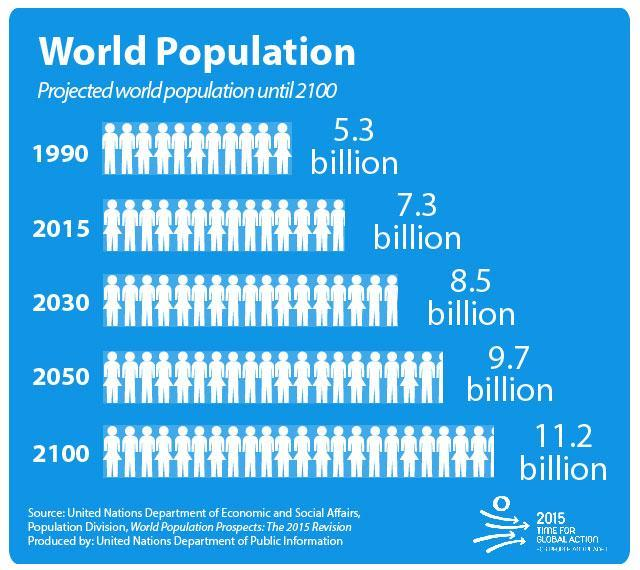What is the difference between the population in 2015 and 1990?
Answer the question with a short phrase. 2 billion What is the difference between the population in 2100  and 2050? 1.5 billion What is the difference between the population in 2050  and 2030? 1.2 billion What is the difference between the population in 2030  and 2015? 1.2 billion 